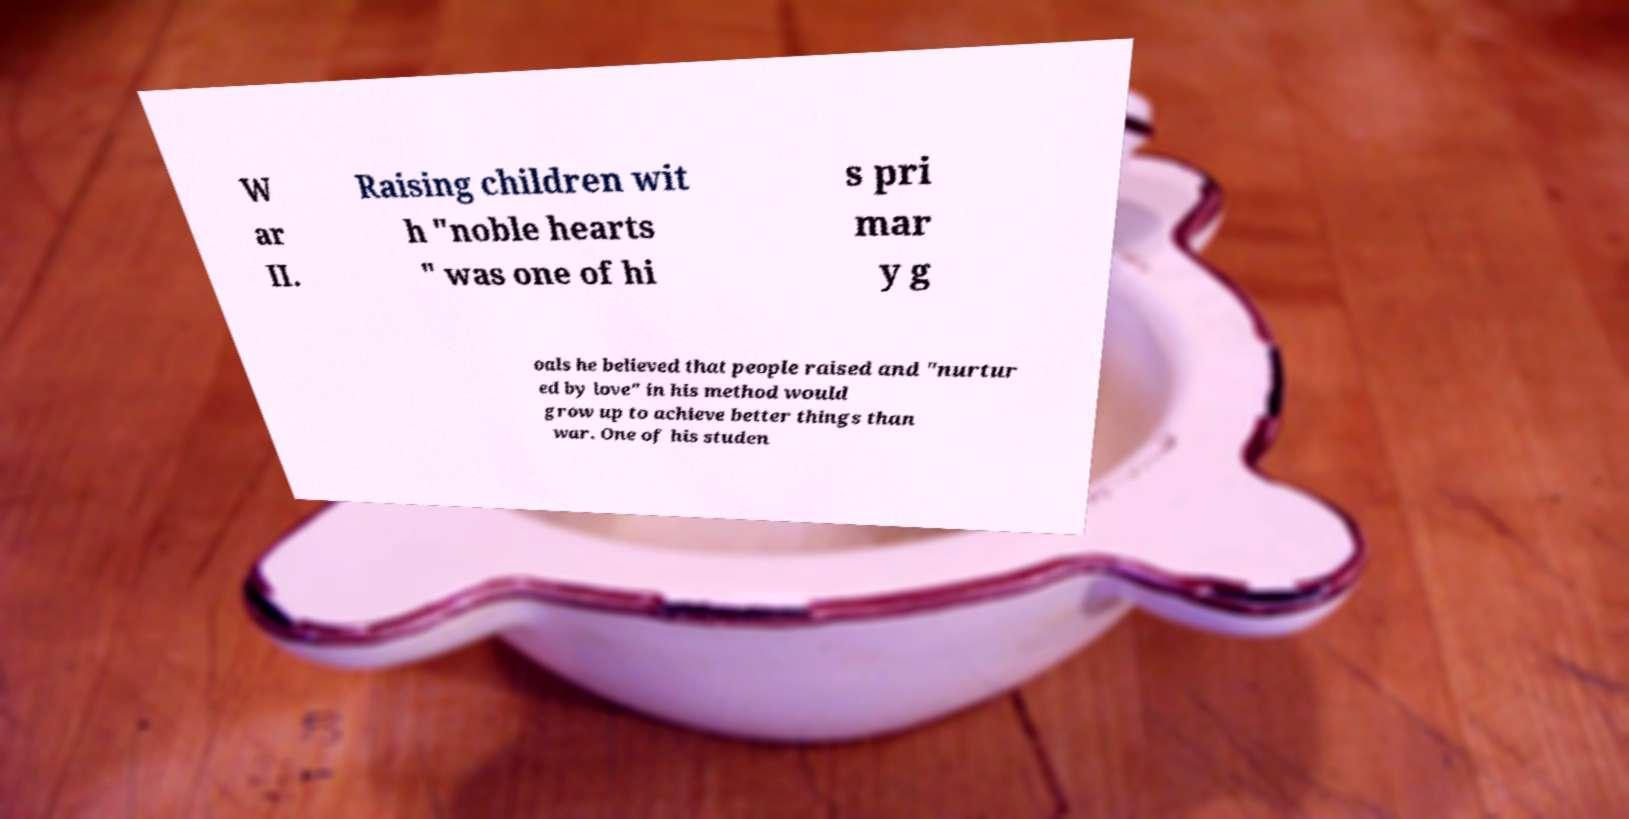Can you accurately transcribe the text from the provided image for me? W ar II. Raising children wit h "noble hearts " was one of hi s pri mar y g oals he believed that people raised and "nurtur ed by love" in his method would grow up to achieve better things than war. One of his studen 